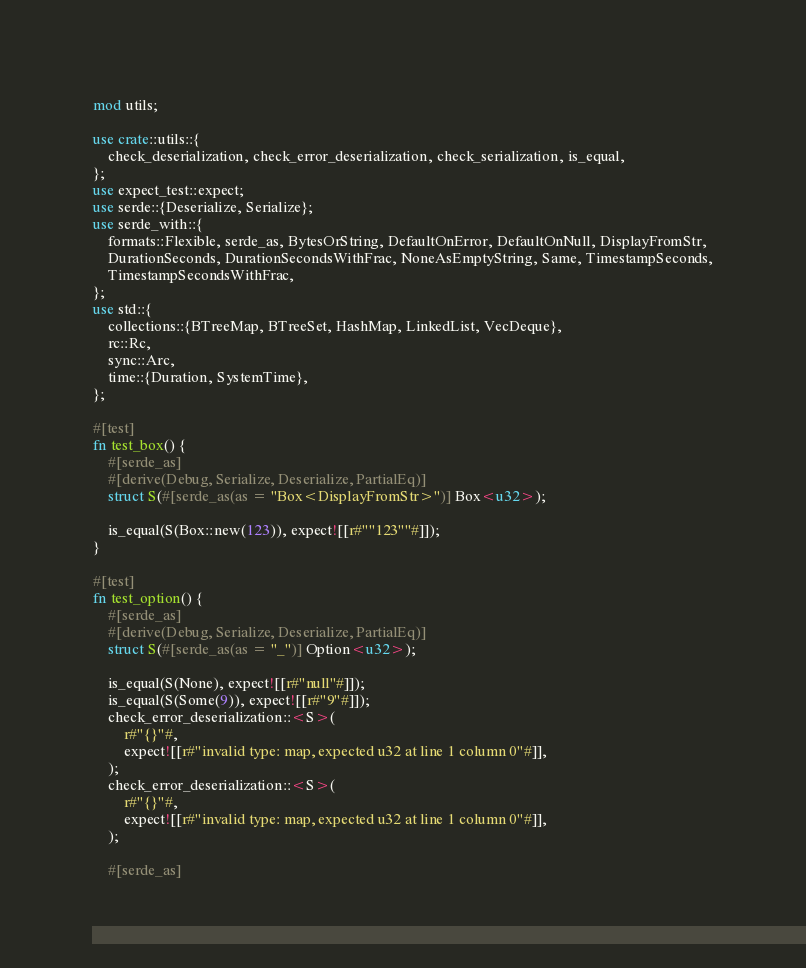Convert code to text. <code><loc_0><loc_0><loc_500><loc_500><_Rust_>mod utils;

use crate::utils::{
    check_deserialization, check_error_deserialization, check_serialization, is_equal,
};
use expect_test::expect;
use serde::{Deserialize, Serialize};
use serde_with::{
    formats::Flexible, serde_as, BytesOrString, DefaultOnError, DefaultOnNull, DisplayFromStr,
    DurationSeconds, DurationSecondsWithFrac, NoneAsEmptyString, Same, TimestampSeconds,
    TimestampSecondsWithFrac,
};
use std::{
    collections::{BTreeMap, BTreeSet, HashMap, LinkedList, VecDeque},
    rc::Rc,
    sync::Arc,
    time::{Duration, SystemTime},
};

#[test]
fn test_box() {
    #[serde_as]
    #[derive(Debug, Serialize, Deserialize, PartialEq)]
    struct S(#[serde_as(as = "Box<DisplayFromStr>")] Box<u32>);

    is_equal(S(Box::new(123)), expect![[r#""123""#]]);
}

#[test]
fn test_option() {
    #[serde_as]
    #[derive(Debug, Serialize, Deserialize, PartialEq)]
    struct S(#[serde_as(as = "_")] Option<u32>);

    is_equal(S(None), expect![[r#"null"#]]);
    is_equal(S(Some(9)), expect![[r#"9"#]]);
    check_error_deserialization::<S>(
        r#"{}"#,
        expect![[r#"invalid type: map, expected u32 at line 1 column 0"#]],
    );
    check_error_deserialization::<S>(
        r#"{}"#,
        expect![[r#"invalid type: map, expected u32 at line 1 column 0"#]],
    );

    #[serde_as]</code> 